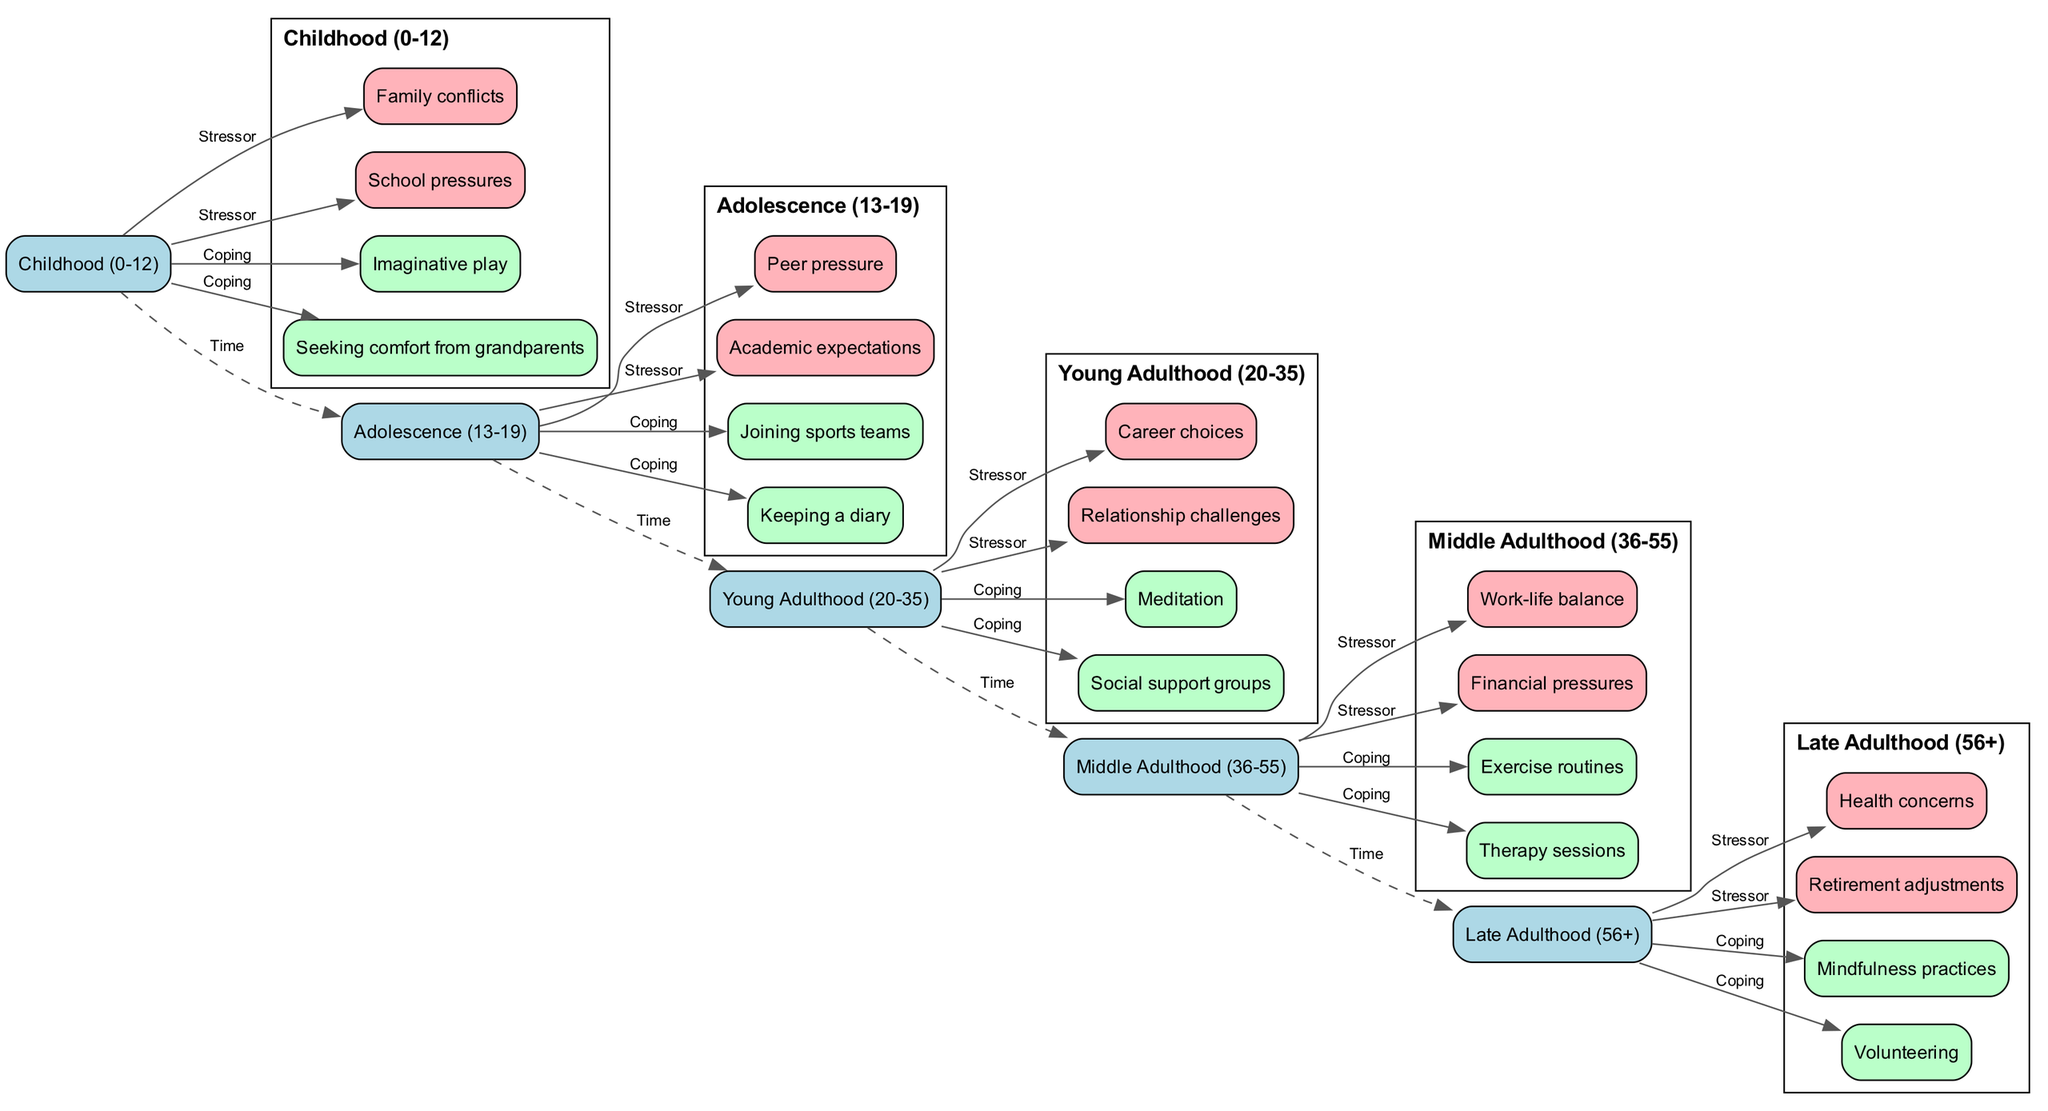What are the stressors in Young Adulthood? The diagram shows that the stressors for the age group Young Adulthood (20-35) are "Career choices" and "Relationship challenges." These stressors can be directly identified under this age group in the diagram.
Answer: Career choices, Relationship challenges How many age groups are represented in the timeline? By counting the distinct age groups in the diagram, we find there are five: Childhood, Adolescence, Young Adulthood, Middle Adulthood, and Late Adulthood. Thus, the answer is five.
Answer: 5 What coping mechanism is associated with Middle Adulthood? The diagram indicates that the coping mechanisms for Middle Adulthood (36-55) include "Exercise routines" and "Therapy sessions." One of these mechanisms can be selected as an answer.
Answer: Exercise routines, Therapy sessions Which age group faces stressors related to peer pressure? According to the diagram, the age group that experiences stressors related to peer pressure is Adolescence (13-19). This can be verified by looking at the respective stressors listed under this age group.
Answer: Adolescence How are stressors and coping mechanisms related in Young Adulthood? In the diagram, we see a direct connection where the stressors "Career choices" and "Relationship challenges" lead to coping mechanisms such as "Meditation" and "Social support groups." This illustrates how the age group's stressors influence their coping strategies.
Answer: Career choices, Relationship challenges → Meditation, Social support groups What is the relationship between Late Adulthood and health concerns? The diagram shows that in Late Adulthood (56+), health concerns are listed as one of the stressors, suggesting that this age group experiences stress due to health-related issues. The connection is direct, as these stressors are highlighted under the respective age group in the diagram.
Answer: Late Adulthood experiences health concerns as a stressor How do coping mechanisms change from Adolescence to Young Adulthood? The diagram reveals that while Adolescents might cope with stress through "Joining sports teams" and "Keeping a diary," Young Adults shift towards methods like "Meditation" and "Social support groups." This change signifies a transition in coping strategies between these two age groups.
Answer: From joining sports teams and keeping a diary to meditation and social support groups What coping mechanism is unique to Late Adulthood? In the diagram, "Volunteering" is listed as a coping mechanism specifically associated with Late Adulthood (56+), indicating how this age group may find purpose and community engagement through volunteering as a stress relief method.
Answer: Volunteering 